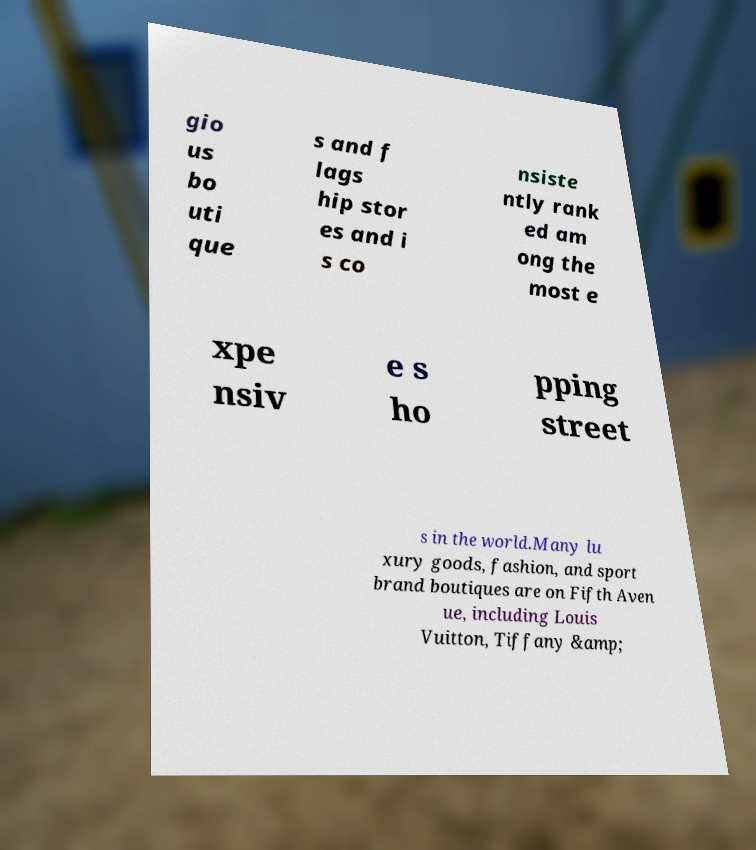There's text embedded in this image that I need extracted. Can you transcribe it verbatim? gio us bo uti que s and f lags hip stor es and i s co nsiste ntly rank ed am ong the most e xpe nsiv e s ho pping street s in the world.Many lu xury goods, fashion, and sport brand boutiques are on Fifth Aven ue, including Louis Vuitton, Tiffany &amp; 